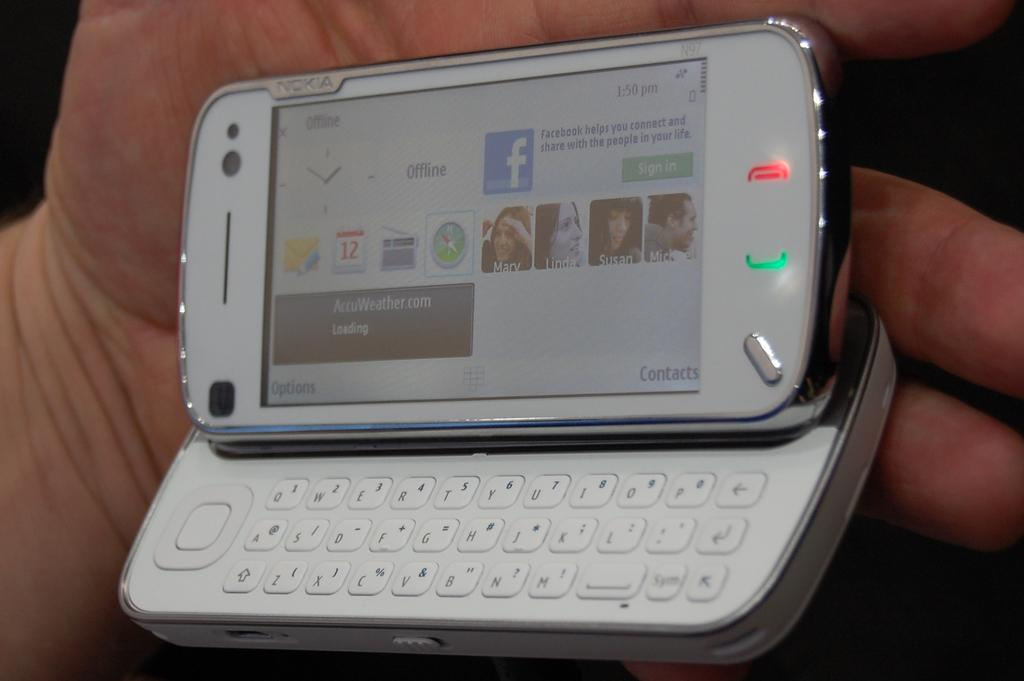<image>
Relay a brief, clear account of the picture shown. A facebook app is shown on the phone screen 